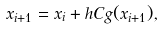Convert formula to latex. <formula><loc_0><loc_0><loc_500><loc_500>x _ { i + 1 } = x _ { i } + h C g ( x _ { i + 1 } ) ,</formula> 